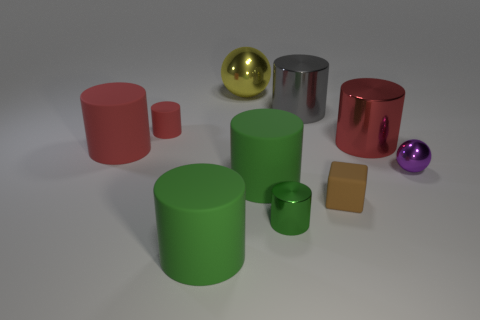What is the material of the big red cylinder right of the big red cylinder left of the shiny sphere behind the small ball?
Offer a terse response. Metal. Do the small cylinder that is in front of the tiny ball and the small metallic ball have the same color?
Provide a succinct answer. No. The large thing that is both behind the small matte cylinder and right of the green metal cylinder is what color?
Your answer should be compact. Gray. What is the shape of the yellow thing that is the same size as the gray object?
Provide a short and direct response. Sphere. Is there another thing of the same shape as the small red object?
Your answer should be very brief. Yes. Does the metallic sphere on the left side of the brown matte cube have the same size as the brown matte thing?
Keep it short and to the point. No. How big is the thing that is both on the left side of the small brown block and on the right side of the tiny green thing?
Give a very brief answer. Large. What number of other objects are the same material as the large yellow thing?
Offer a terse response. 4. What size is the red object right of the large gray shiny thing?
Make the answer very short. Large. How many tiny things are either gray metal objects or red rubber cylinders?
Keep it short and to the point. 1. 